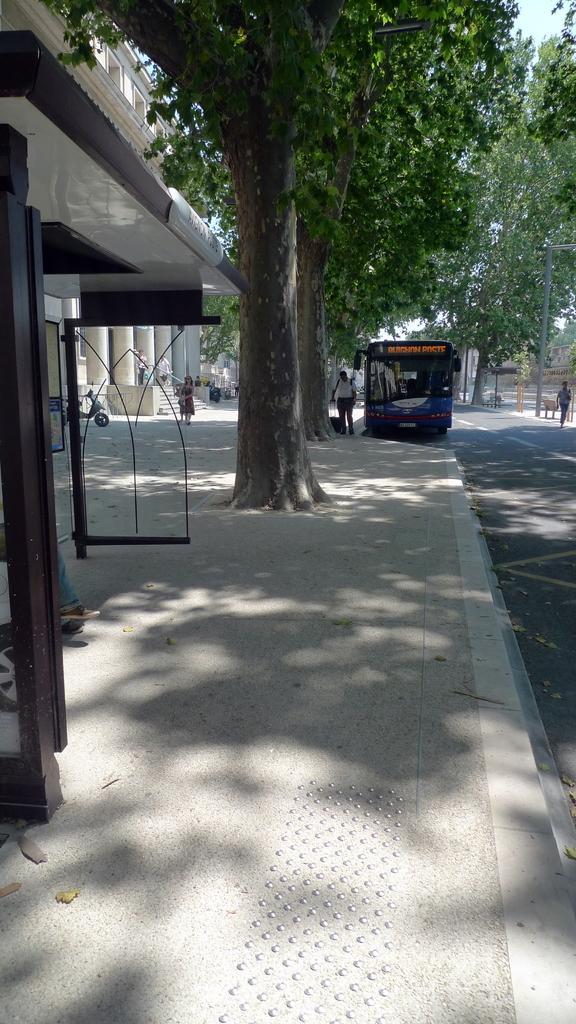How would you summarize this image in a sentence or two? In the picture we can see the sidewalk, bus shelter, trees, bus on the road, we can see scooter, steps and a pole in the background. 